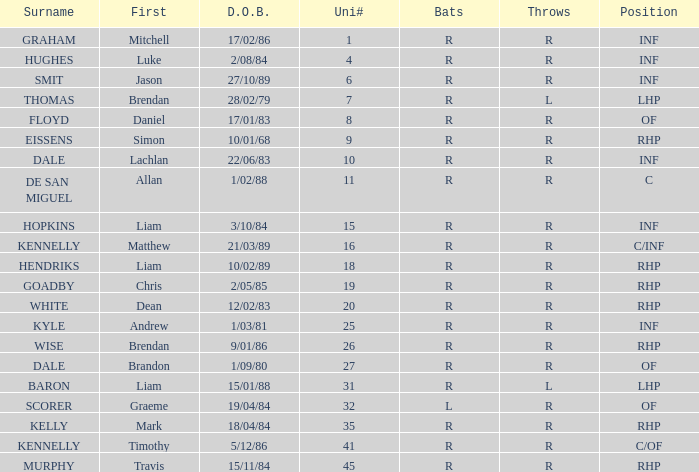Which participant has a last name of baron? R. 